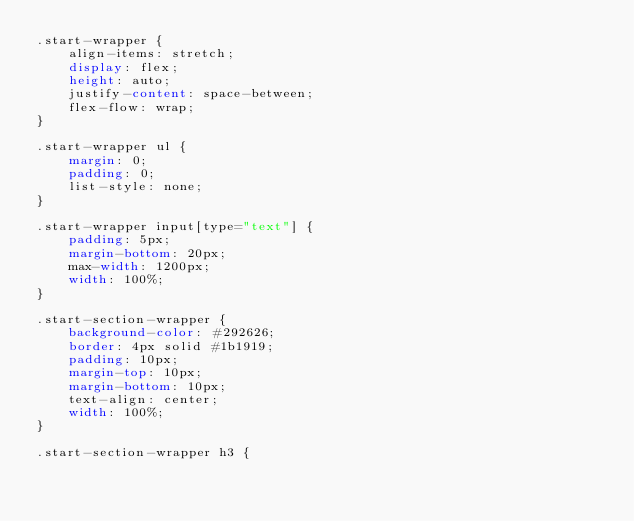<code> <loc_0><loc_0><loc_500><loc_500><_CSS_>.start-wrapper {
    align-items: stretch;
    display: flex;
    height: auto;
    justify-content: space-between;
    flex-flow: wrap;
}

.start-wrapper ul {
    margin: 0;
    padding: 0;
    list-style: none;
}

.start-wrapper input[type="text"] {
    padding: 5px;
    margin-bottom: 20px;
    max-width: 1200px;
    width: 100%;
}

.start-section-wrapper {
    background-color: #292626;
    border: 4px solid #1b1919;
    padding: 10px;
    margin-top: 10px;
    margin-bottom: 10px;
    text-align: center;
    width: 100%;
}

.start-section-wrapper h3 {</code> 